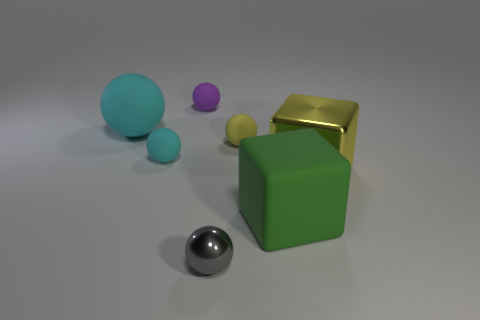Subtract all purple spheres. How many spheres are left? 4 Subtract all tiny yellow matte balls. How many balls are left? 4 Subtract 2 balls. How many balls are left? 3 Subtract all blue balls. Subtract all purple blocks. How many balls are left? 5 Add 2 big brown shiny blocks. How many objects exist? 9 Subtract all cubes. How many objects are left? 5 Add 1 large matte objects. How many large matte objects are left? 3 Add 7 large cyan rubber cubes. How many large cyan rubber cubes exist? 7 Subtract 0 brown balls. How many objects are left? 7 Subtract all big blue rubber spheres. Subtract all gray things. How many objects are left? 6 